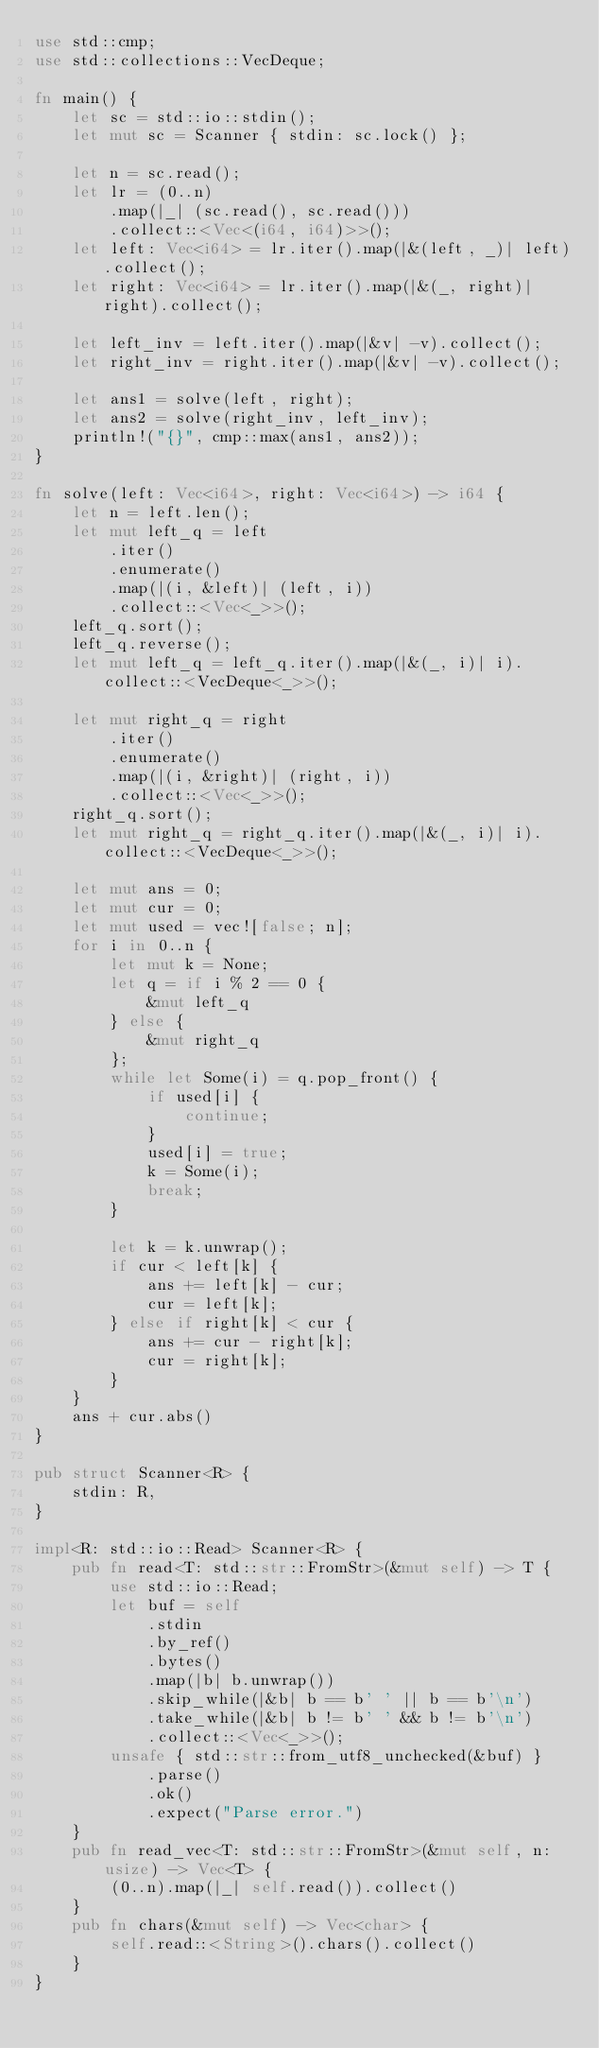<code> <loc_0><loc_0><loc_500><loc_500><_Rust_>use std::cmp;
use std::collections::VecDeque;

fn main() {
    let sc = std::io::stdin();
    let mut sc = Scanner { stdin: sc.lock() };

    let n = sc.read();
    let lr = (0..n)
        .map(|_| (sc.read(), sc.read()))
        .collect::<Vec<(i64, i64)>>();
    let left: Vec<i64> = lr.iter().map(|&(left, _)| left).collect();
    let right: Vec<i64> = lr.iter().map(|&(_, right)| right).collect();

    let left_inv = left.iter().map(|&v| -v).collect();
    let right_inv = right.iter().map(|&v| -v).collect();

    let ans1 = solve(left, right);
    let ans2 = solve(right_inv, left_inv);
    println!("{}", cmp::max(ans1, ans2));
}

fn solve(left: Vec<i64>, right: Vec<i64>) -> i64 {
    let n = left.len();
    let mut left_q = left
        .iter()
        .enumerate()
        .map(|(i, &left)| (left, i))
        .collect::<Vec<_>>();
    left_q.sort();
    left_q.reverse();
    let mut left_q = left_q.iter().map(|&(_, i)| i).collect::<VecDeque<_>>();

    let mut right_q = right
        .iter()
        .enumerate()
        .map(|(i, &right)| (right, i))
        .collect::<Vec<_>>();
    right_q.sort();
    let mut right_q = right_q.iter().map(|&(_, i)| i).collect::<VecDeque<_>>();

    let mut ans = 0;
    let mut cur = 0;
    let mut used = vec![false; n];
    for i in 0..n {
        let mut k = None;
        let q = if i % 2 == 0 {
            &mut left_q
        } else {
            &mut right_q
        };
        while let Some(i) = q.pop_front() {
            if used[i] {
                continue;
            }
            used[i] = true;
            k = Some(i);
            break;
        }

        let k = k.unwrap();
        if cur < left[k] {
            ans += left[k] - cur;
            cur = left[k];
        } else if right[k] < cur {
            ans += cur - right[k];
            cur = right[k];
        }
    }
    ans + cur.abs()
}

pub struct Scanner<R> {
    stdin: R,
}

impl<R: std::io::Read> Scanner<R> {
    pub fn read<T: std::str::FromStr>(&mut self) -> T {
        use std::io::Read;
        let buf = self
            .stdin
            .by_ref()
            .bytes()
            .map(|b| b.unwrap())
            .skip_while(|&b| b == b' ' || b == b'\n')
            .take_while(|&b| b != b' ' && b != b'\n')
            .collect::<Vec<_>>();
        unsafe { std::str::from_utf8_unchecked(&buf) }
            .parse()
            .ok()
            .expect("Parse error.")
    }
    pub fn read_vec<T: std::str::FromStr>(&mut self, n: usize) -> Vec<T> {
        (0..n).map(|_| self.read()).collect()
    }
    pub fn chars(&mut self) -> Vec<char> {
        self.read::<String>().chars().collect()
    }
}
</code> 